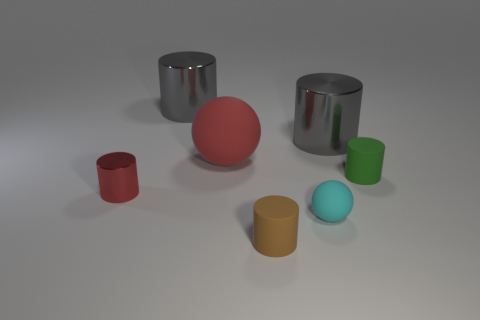Subtract all gray cylinders. How many were subtracted if there are1gray cylinders left? 1 Subtract all tiny red metallic cylinders. How many cylinders are left? 4 Subtract 1 cylinders. How many cylinders are left? 4 Add 1 small objects. How many objects exist? 8 Subtract all brown cylinders. How many cylinders are left? 4 Subtract all cylinders. How many objects are left? 2 Subtract all blue cylinders. Subtract all yellow balls. How many cylinders are left? 5 Subtract all tiny blue shiny things. Subtract all big gray metal cylinders. How many objects are left? 5 Add 5 tiny cylinders. How many tiny cylinders are left? 8 Add 5 big brown rubber cylinders. How many big brown rubber cylinders exist? 5 